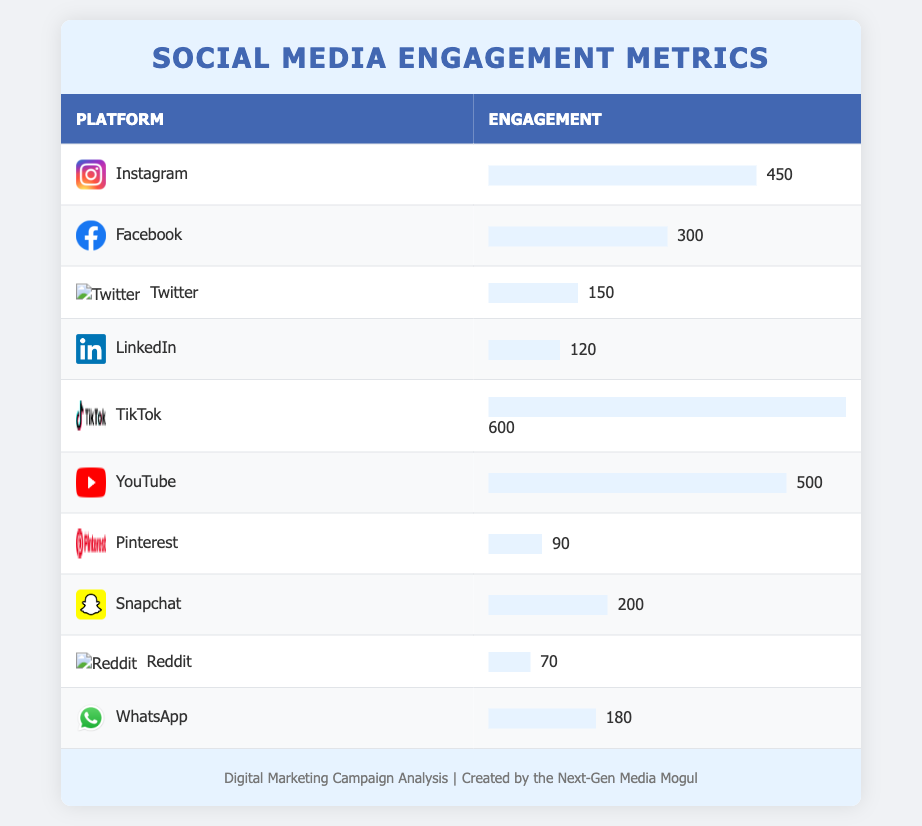What is the platform with the highest engagement? Looking at the engagement values, TikTok has the highest engagement at 600, which is greater than all other platforms listed.
Answer: TikTok What is the engagement level for Facebook? The table shows that Facebook has an engagement level of 300.
Answer: 300 Which platforms have an engagement lower than 200? By examining the engagement levels, Pinterest (90) and Reddit (70) have engagement levels below 200.
Answer: Pinterest and Reddit What is the total engagement across all platforms? To find the total engagement, we sum up the values: 450 + 300 + 150 + 120 + 600 + 500 + 90 + 200 + 70 + 180 = 2660.
Answer: 2660 Is the engagement on YouTube greater than that on Snapchat? Comparing the values, YouTube has an engagement of 500 while Snapchat has an engagement of 200, so YouTube's engagement is indeed greater.
Answer: Yes What is the average engagement of all platforms? First, we calculate the total engagement (2660) and then divide by the number of platforms (10). The average engagement is 2660 / 10 = 266.
Answer: 266 Which platform has engagement exactly 150? Checking the table, Twitter shows an engagement of 150.
Answer: Twitter Are there more platforms with engagement greater than 400 or less than 100? Platforms with engagement greater than 400 are TikTok (600), YouTube (500), and Instagram (450), totaling 3. Platforms with engagement less than 100 are Pinterest (90) and Reddit (70), totaling 2. Thus, there are more platforms with engagement greater than 400.
Answer: More platforms have engagement greater than 400 What is the difference in engagement between the platform with the highest and the lowest engagement? TikTok has the highest engagement at 600 and Reddit has the lowest at 70. The difference is 600 - 70 = 530.
Answer: 530 